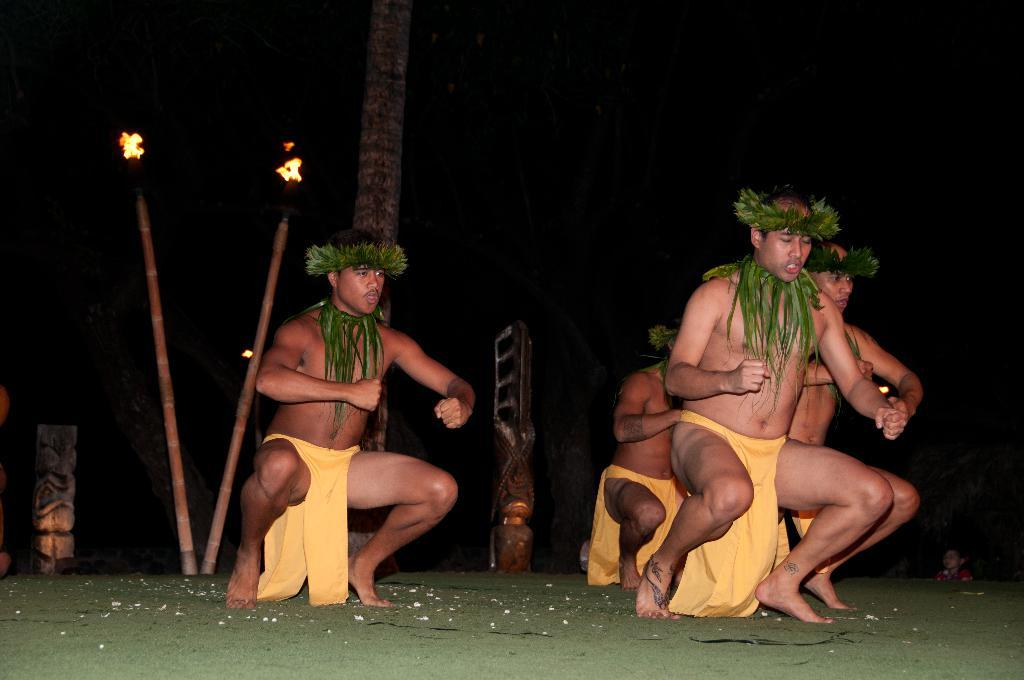How many people are in the image? There are four men in the image. What are the men doing in the image? The men are dancing on a stage. What can be seen in the background of the image? There is a stick and a wall visible in the background. What type of banana is being used as a prop by one of the dancers in the image? There is no banana present in the image; the men are dancing without any props. 